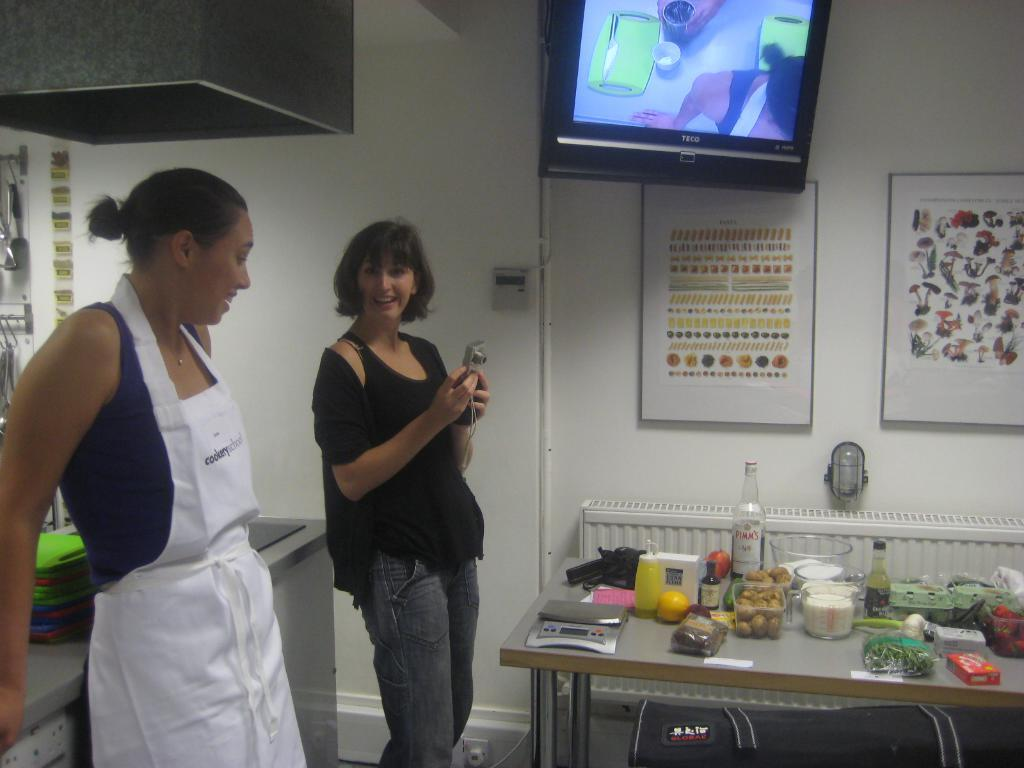<image>
Give a short and clear explanation of the subsequent image. 2 women in a kitchen preparing food for customers to eat; there is a Teco television hanging from the top. 